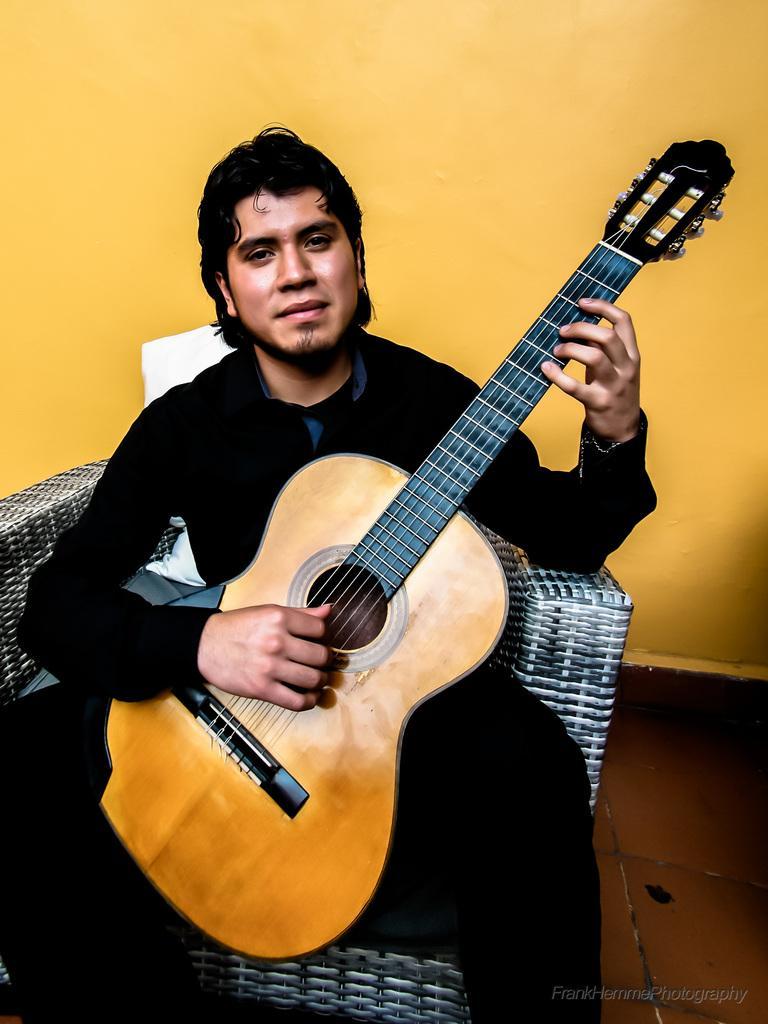How would you summarize this image in a sentence or two? A man with black dress is sitting on a chair. In his hand there is a guitar. He is playing a guitar. He is smiling. In the background there is a wall with yellow color. 